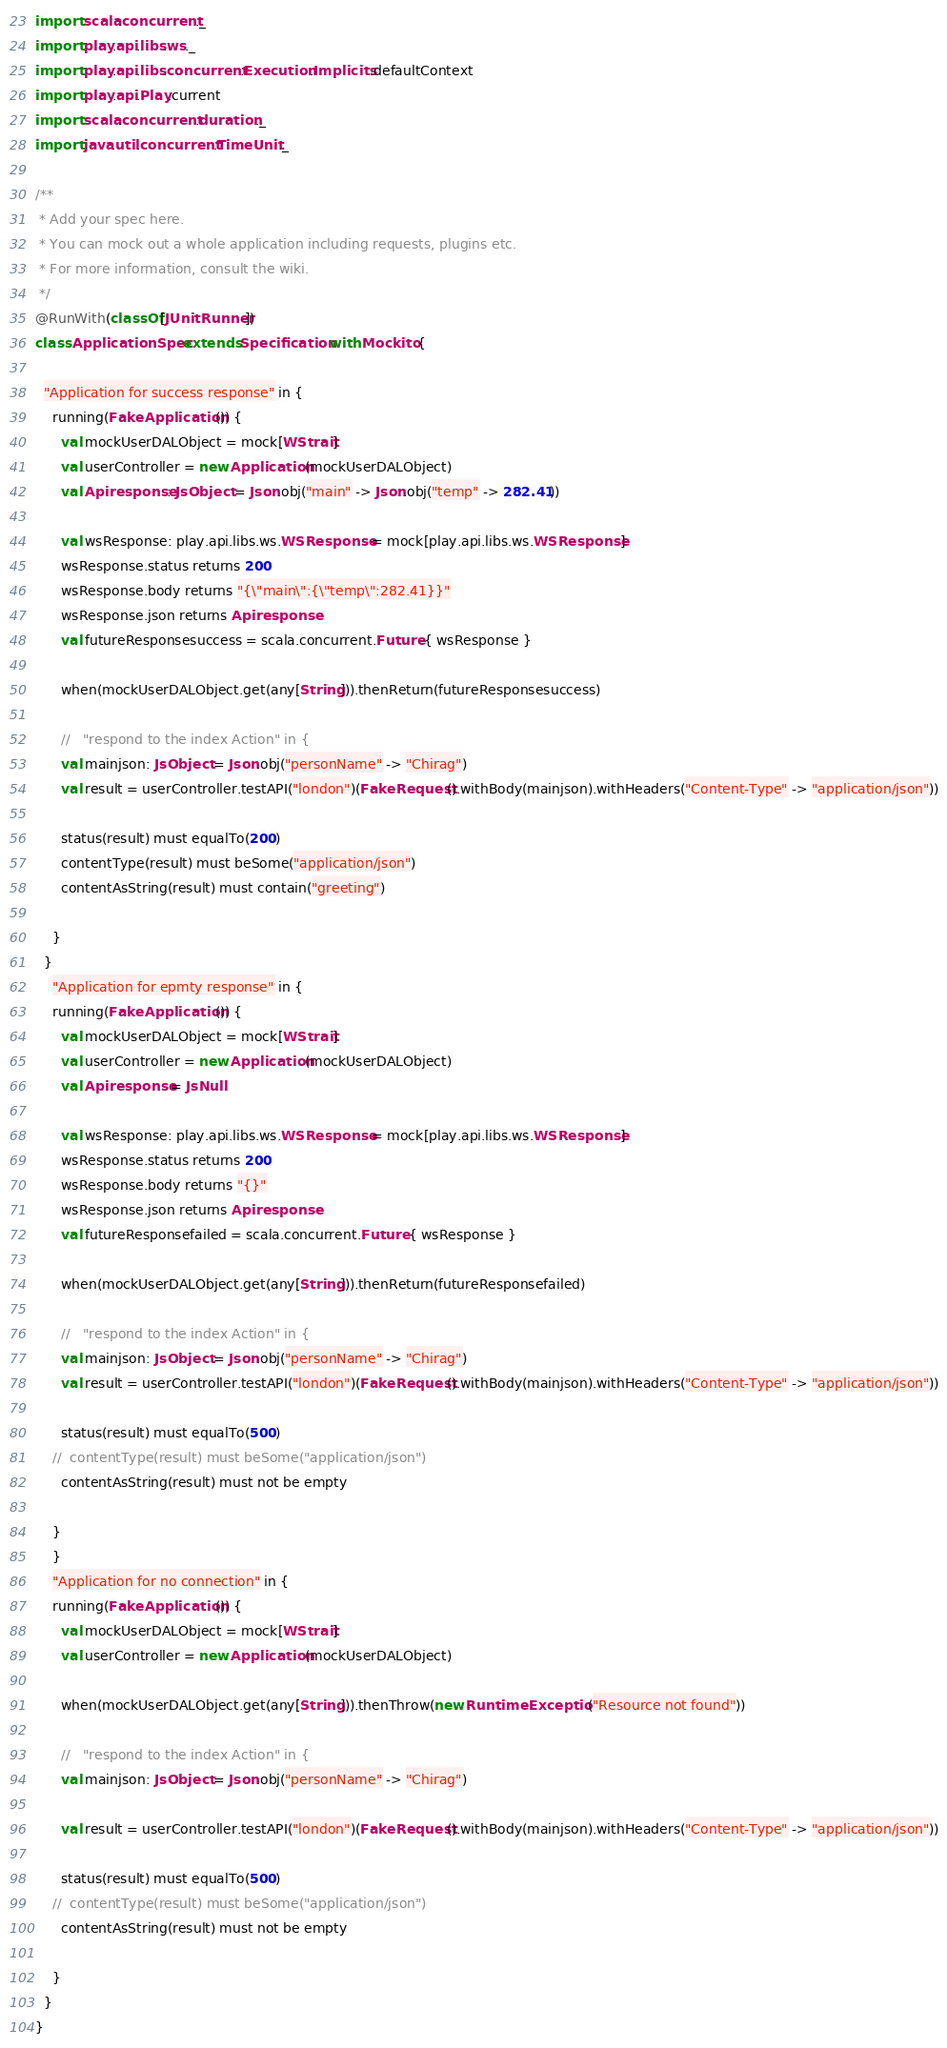<code> <loc_0><loc_0><loc_500><loc_500><_Scala_>import scala.concurrent._
import play.api.libs.ws._
import play.api.libs.concurrent.Execution.Implicits.defaultContext
import play.api.Play.current
import scala.concurrent.duration._
import java.util.concurrent.TimeUnit._

/**
 * Add your spec here.
 * You can mock out a whole application including requests, plugins etc.
 * For more information, consult the wiki.
 */
@RunWith(classOf[JUnitRunner])
class ApplicationSpec extends Specification with Mockito {

  "Application for success response" in {
    running(FakeApplication()) {
      val mockUserDALObject = mock[WStrait]
      val userController = new Application(mockUserDALObject)
      val Apiresponse: JsObject = Json.obj("main" -> Json.obj("temp" -> 282.41))

      val wsResponse: play.api.libs.ws.WSResponse = mock[play.api.libs.ws.WSResponse]
      wsResponse.status returns 200
      wsResponse.body returns "{\"main\":{\"temp\":282.41}}"
      wsResponse.json returns Apiresponse
      val futureResponsesuccess = scala.concurrent.Future { wsResponse }

      when(mockUserDALObject.get(any[String])).thenReturn(futureResponsesuccess)

      //   "respond to the index Action" in {
      val mainjson: JsObject = Json.obj("personName" -> "Chirag")
      val result = userController.testAPI("london")(FakeRequest().withBody(mainjson).withHeaders("Content-Type" -> "application/json"))

      status(result) must equalTo(200)
      contentType(result) must beSome("application/json")
      contentAsString(result) must contain("greeting")

    }
  }
    "Application for epmty response" in {
    running(FakeApplication()) {
      val mockUserDALObject = mock[WStrait]
      val userController = new Application(mockUserDALObject)
      val Apiresponse = JsNull

      val wsResponse: play.api.libs.ws.WSResponse = mock[play.api.libs.ws.WSResponse]
      wsResponse.status returns 200
      wsResponse.body returns "{}"
      wsResponse.json returns Apiresponse
      val futureResponsefailed = scala.concurrent.Future { wsResponse }

      when(mockUserDALObject.get(any[String])).thenReturn(futureResponsefailed)

      //   "respond to the index Action" in {
      val mainjson: JsObject = Json.obj("personName" -> "Chirag")
      val result = userController.testAPI("london")(FakeRequest().withBody(mainjson).withHeaders("Content-Type" -> "application/json"))

      status(result) must equalTo(500)
    //  contentType(result) must beSome("application/json")
      contentAsString(result) must not be empty

    }
    }
    "Application for no connection" in {
    running(FakeApplication()) {
      val mockUserDALObject = mock[WStrait]
      val userController = new Application(mockUserDALObject)

      when(mockUserDALObject.get(any[String])).thenThrow(new RuntimeException("Resource not found"))

      //   "respond to the index Action" in {
      val mainjson: JsObject = Json.obj("personName" -> "Chirag")
      
      val result = userController.testAPI("london")(FakeRequest().withBody(mainjson).withHeaders("Content-Type" -> "application/json"))

      status(result) must equalTo(500)
    //  contentType(result) must beSome("application/json")
      contentAsString(result) must not be empty

    }
  }
}
</code> 